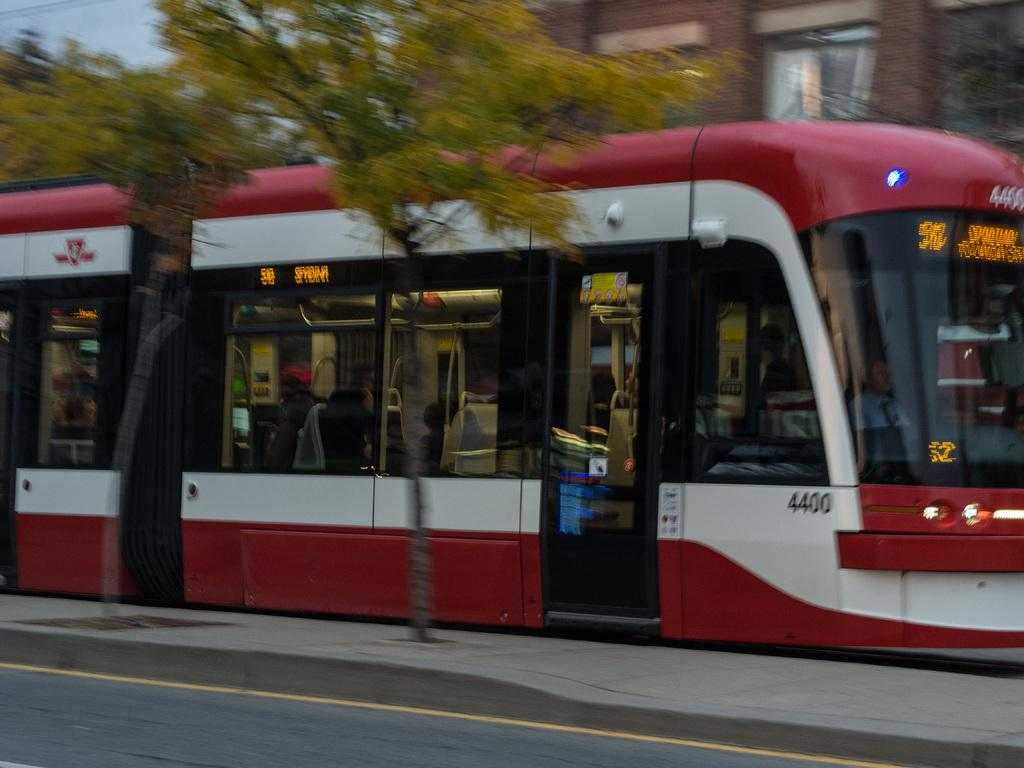What type of vegetation can be seen in the image? There are trees in the image. What mode of transportation are the persons using in the image? The persons are riding in a bus in the image. Where is the bus located in the image? The bus is on a road in the image. What can be seen in the background of the image? There is a building, a window, trees, and the sky visible in the background of the image. Can you tell me how many socks the aunt is wearing in the image? There is no aunt or socks present in the image. What type of snake can be seen slithering in the background of the image? There is no snake present in the image; only trees, a building, a window, and the sky are visible in the background. 